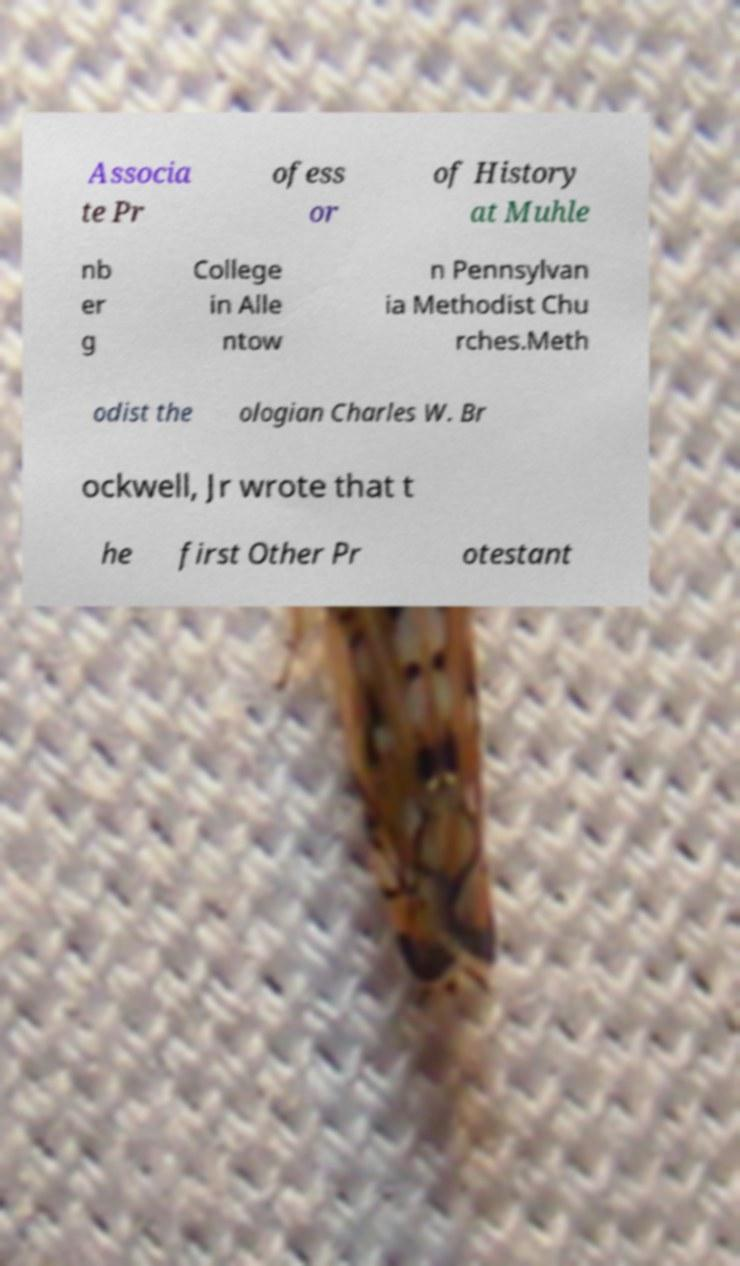What messages or text are displayed in this image? I need them in a readable, typed format. Associa te Pr ofess or of History at Muhle nb er g College in Alle ntow n Pennsylvan ia Methodist Chu rches.Meth odist the ologian Charles W. Br ockwell, Jr wrote that t he first Other Pr otestant 